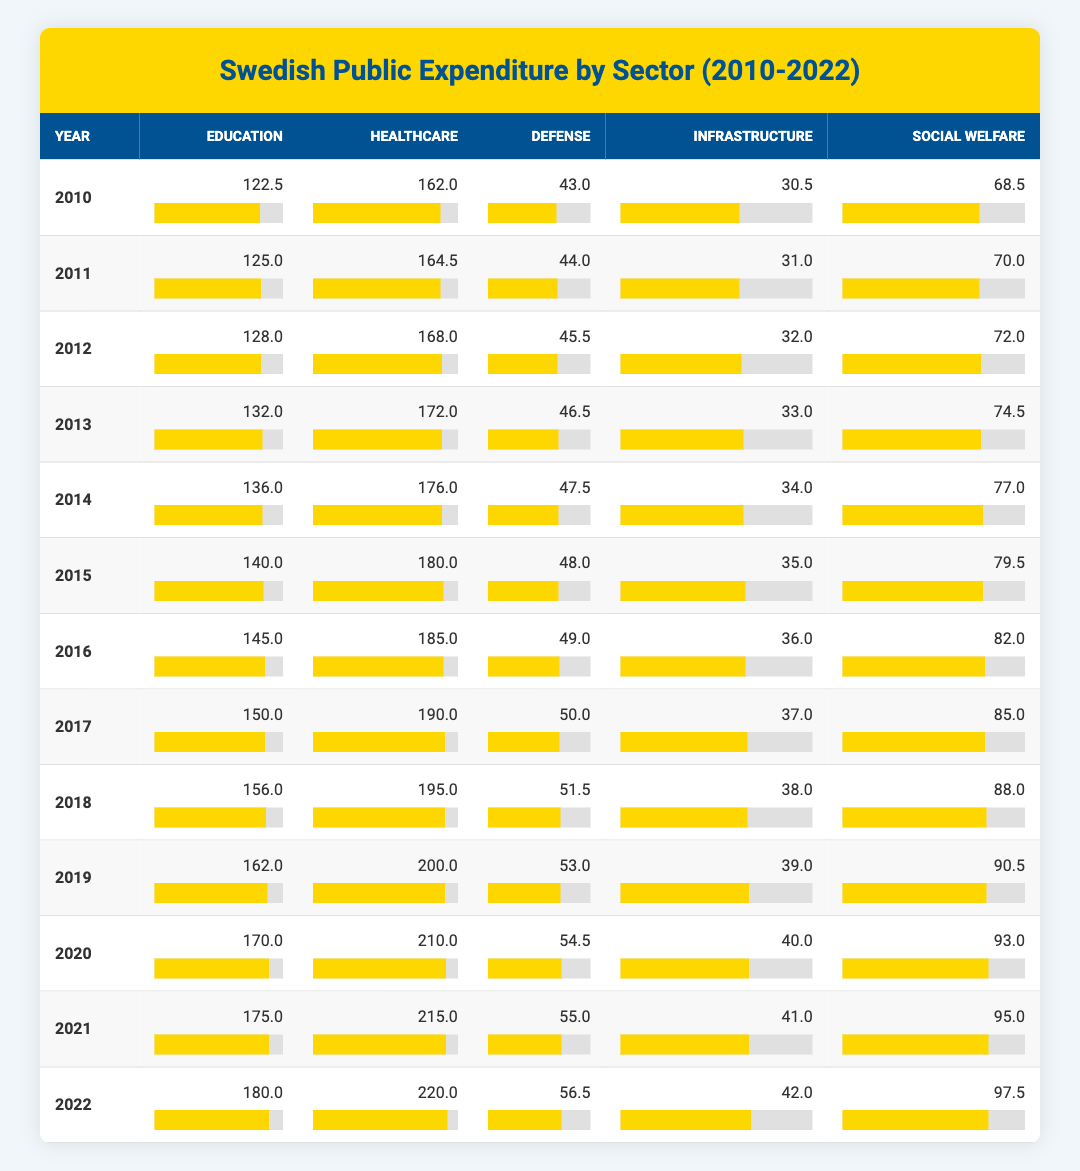What was the total public expenditure on healthcare in 2022? The expenditure for healthcare in 2022 is listed as 220.0.
Answer: 220.0 Which sector had the least expenditure in 2010? In 2010, the defense expenditures were 43.0, which is less than the expenditures in all other sectors listed for that year.
Answer: Defense What is the percentage increase in public expenditure on education from 2010 to 2022? The expenditure on education in 2010 was 122.5 and increased to 180.0 in 2022. The increase is (180.0 - 122.5) / 122.5 * 100 = 47.0%.
Answer: 47.0% Did the social welfare expenditure exceed 95.0 at any point between 2010 and 2022? Upon reviewing the table, social welfare exceeded 95.0 in 2022, when it was 97.5.
Answer: Yes What was the average public expenditure on infrastructure from 2010 to 2022? The infrastructure expenditures from 2010 to 2022 are: 30.5, 31.0, 32.0, 33.0, 34.0, 35.0, 36.0, 37.0, 38.0, 39.0, 40.0, 41.0, 42.0. Summing these amounts gives 174.5. Dividing by the number of years (13) gives an average of 174.5 / 13 = 13.38.
Answer: 35.00 What was the total expenditure on defense in 2013 and 2014 combined? In 2013, the defense expenditure was 46.5, and in 2014, it was 47.5. Their combined total is 46.5 + 47.5 = 94.0.
Answer: 94.0 